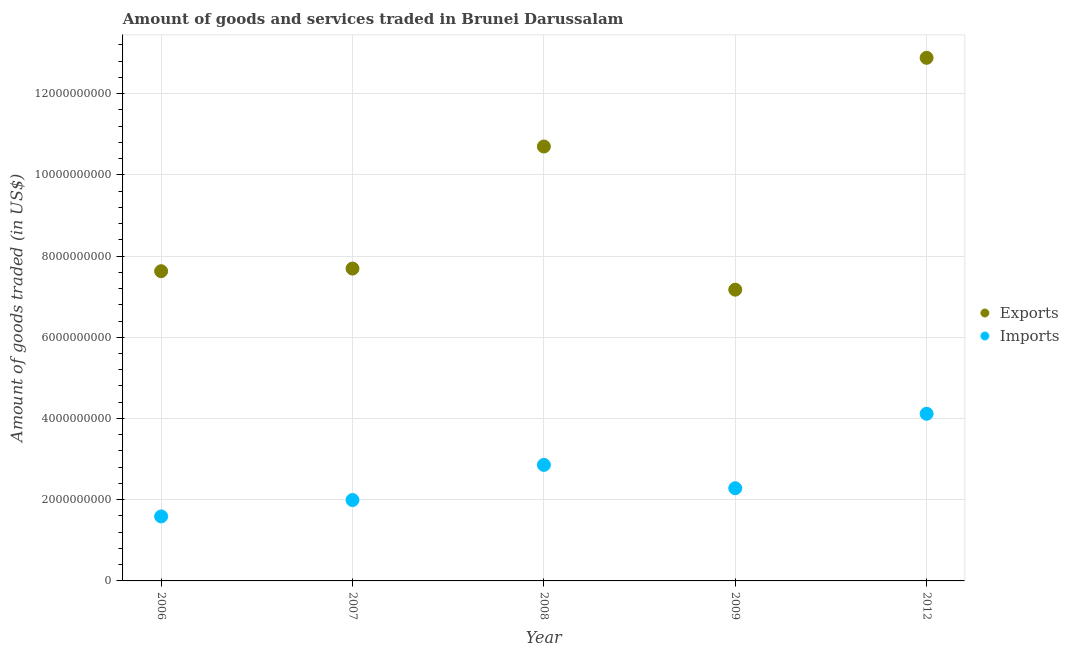What is the amount of goods exported in 2006?
Make the answer very short. 7.63e+09. Across all years, what is the maximum amount of goods imported?
Provide a short and direct response. 4.12e+09. Across all years, what is the minimum amount of goods exported?
Provide a succinct answer. 7.17e+09. In which year was the amount of goods exported maximum?
Provide a short and direct response. 2012. What is the total amount of goods exported in the graph?
Your answer should be very brief. 4.61e+1. What is the difference between the amount of goods imported in 2006 and that in 2012?
Ensure brevity in your answer.  -2.53e+09. What is the difference between the amount of goods exported in 2006 and the amount of goods imported in 2012?
Your answer should be compact. 3.51e+09. What is the average amount of goods exported per year?
Ensure brevity in your answer.  9.21e+09. In the year 2008, what is the difference between the amount of goods exported and amount of goods imported?
Offer a terse response. 7.84e+09. In how many years, is the amount of goods imported greater than 9600000000 US$?
Your answer should be very brief. 0. What is the ratio of the amount of goods exported in 2006 to that in 2007?
Ensure brevity in your answer.  0.99. Is the amount of goods exported in 2007 less than that in 2012?
Your response must be concise. Yes. Is the difference between the amount of goods exported in 2006 and 2012 greater than the difference between the amount of goods imported in 2006 and 2012?
Offer a terse response. No. What is the difference between the highest and the second highest amount of goods exported?
Provide a succinct answer. 2.18e+09. What is the difference between the highest and the lowest amount of goods exported?
Provide a short and direct response. 5.71e+09. In how many years, is the amount of goods imported greater than the average amount of goods imported taken over all years?
Your answer should be compact. 2. Does the amount of goods imported monotonically increase over the years?
Provide a succinct answer. No. Is the amount of goods imported strictly less than the amount of goods exported over the years?
Provide a short and direct response. Yes. How many dotlines are there?
Keep it short and to the point. 2. Are the values on the major ticks of Y-axis written in scientific E-notation?
Give a very brief answer. No. Does the graph contain grids?
Keep it short and to the point. Yes. Where does the legend appear in the graph?
Make the answer very short. Center right. How many legend labels are there?
Ensure brevity in your answer.  2. How are the legend labels stacked?
Provide a succinct answer. Vertical. What is the title of the graph?
Your answer should be compact. Amount of goods and services traded in Brunei Darussalam. What is the label or title of the Y-axis?
Offer a very short reply. Amount of goods traded (in US$). What is the Amount of goods traded (in US$) in Exports in 2006?
Your answer should be compact. 7.63e+09. What is the Amount of goods traded (in US$) of Imports in 2006?
Offer a very short reply. 1.59e+09. What is the Amount of goods traded (in US$) of Exports in 2007?
Give a very brief answer. 7.69e+09. What is the Amount of goods traded (in US$) of Imports in 2007?
Your response must be concise. 1.99e+09. What is the Amount of goods traded (in US$) in Exports in 2008?
Provide a succinct answer. 1.07e+1. What is the Amount of goods traded (in US$) in Imports in 2008?
Keep it short and to the point. 2.86e+09. What is the Amount of goods traded (in US$) of Exports in 2009?
Ensure brevity in your answer.  7.17e+09. What is the Amount of goods traded (in US$) of Imports in 2009?
Your answer should be compact. 2.28e+09. What is the Amount of goods traded (in US$) of Exports in 2012?
Your answer should be compact. 1.29e+1. What is the Amount of goods traded (in US$) in Imports in 2012?
Your response must be concise. 4.12e+09. Across all years, what is the maximum Amount of goods traded (in US$) in Exports?
Make the answer very short. 1.29e+1. Across all years, what is the maximum Amount of goods traded (in US$) of Imports?
Your answer should be compact. 4.12e+09. Across all years, what is the minimum Amount of goods traded (in US$) of Exports?
Make the answer very short. 7.17e+09. Across all years, what is the minimum Amount of goods traded (in US$) of Imports?
Your answer should be compact. 1.59e+09. What is the total Amount of goods traded (in US$) in Exports in the graph?
Your answer should be compact. 4.61e+1. What is the total Amount of goods traded (in US$) in Imports in the graph?
Give a very brief answer. 1.28e+1. What is the difference between the Amount of goods traded (in US$) in Exports in 2006 and that in 2007?
Your answer should be compact. -6.47e+07. What is the difference between the Amount of goods traded (in US$) in Imports in 2006 and that in 2007?
Make the answer very short. -4.03e+08. What is the difference between the Amount of goods traded (in US$) of Exports in 2006 and that in 2008?
Provide a succinct answer. -3.07e+09. What is the difference between the Amount of goods traded (in US$) in Imports in 2006 and that in 2008?
Make the answer very short. -1.27e+09. What is the difference between the Amount of goods traded (in US$) in Exports in 2006 and that in 2009?
Give a very brief answer. 4.55e+08. What is the difference between the Amount of goods traded (in US$) of Imports in 2006 and that in 2009?
Make the answer very short. -6.94e+08. What is the difference between the Amount of goods traded (in US$) of Exports in 2006 and that in 2012?
Make the answer very short. -5.25e+09. What is the difference between the Amount of goods traded (in US$) in Imports in 2006 and that in 2012?
Your answer should be very brief. -2.53e+09. What is the difference between the Amount of goods traded (in US$) in Exports in 2007 and that in 2008?
Your response must be concise. -3.01e+09. What is the difference between the Amount of goods traded (in US$) of Imports in 2007 and that in 2008?
Provide a short and direct response. -8.66e+08. What is the difference between the Amount of goods traded (in US$) in Exports in 2007 and that in 2009?
Give a very brief answer. 5.20e+08. What is the difference between the Amount of goods traded (in US$) in Imports in 2007 and that in 2009?
Give a very brief answer. -2.91e+08. What is the difference between the Amount of goods traded (in US$) of Exports in 2007 and that in 2012?
Your response must be concise. -5.19e+09. What is the difference between the Amount of goods traded (in US$) in Imports in 2007 and that in 2012?
Your answer should be very brief. -2.12e+09. What is the difference between the Amount of goods traded (in US$) in Exports in 2008 and that in 2009?
Offer a very short reply. 3.53e+09. What is the difference between the Amount of goods traded (in US$) of Imports in 2008 and that in 2009?
Offer a very short reply. 5.75e+08. What is the difference between the Amount of goods traded (in US$) of Exports in 2008 and that in 2012?
Offer a very short reply. -2.18e+09. What is the difference between the Amount of goods traded (in US$) of Imports in 2008 and that in 2012?
Make the answer very short. -1.26e+09. What is the difference between the Amount of goods traded (in US$) in Exports in 2009 and that in 2012?
Your answer should be compact. -5.71e+09. What is the difference between the Amount of goods traded (in US$) of Imports in 2009 and that in 2012?
Make the answer very short. -1.83e+09. What is the difference between the Amount of goods traded (in US$) in Exports in 2006 and the Amount of goods traded (in US$) in Imports in 2007?
Your answer should be compact. 5.64e+09. What is the difference between the Amount of goods traded (in US$) in Exports in 2006 and the Amount of goods traded (in US$) in Imports in 2008?
Your answer should be compact. 4.77e+09. What is the difference between the Amount of goods traded (in US$) in Exports in 2006 and the Amount of goods traded (in US$) in Imports in 2009?
Your response must be concise. 5.34e+09. What is the difference between the Amount of goods traded (in US$) in Exports in 2006 and the Amount of goods traded (in US$) in Imports in 2012?
Give a very brief answer. 3.51e+09. What is the difference between the Amount of goods traded (in US$) of Exports in 2007 and the Amount of goods traded (in US$) of Imports in 2008?
Provide a succinct answer. 4.83e+09. What is the difference between the Amount of goods traded (in US$) of Exports in 2007 and the Amount of goods traded (in US$) of Imports in 2009?
Keep it short and to the point. 5.41e+09. What is the difference between the Amount of goods traded (in US$) of Exports in 2007 and the Amount of goods traded (in US$) of Imports in 2012?
Provide a succinct answer. 3.58e+09. What is the difference between the Amount of goods traded (in US$) in Exports in 2008 and the Amount of goods traded (in US$) in Imports in 2009?
Your response must be concise. 8.42e+09. What is the difference between the Amount of goods traded (in US$) in Exports in 2008 and the Amount of goods traded (in US$) in Imports in 2012?
Your response must be concise. 6.58e+09. What is the difference between the Amount of goods traded (in US$) of Exports in 2009 and the Amount of goods traded (in US$) of Imports in 2012?
Offer a very short reply. 3.06e+09. What is the average Amount of goods traded (in US$) of Exports per year?
Provide a succinct answer. 9.21e+09. What is the average Amount of goods traded (in US$) of Imports per year?
Your answer should be compact. 2.57e+09. In the year 2006, what is the difference between the Amount of goods traded (in US$) in Exports and Amount of goods traded (in US$) in Imports?
Provide a succinct answer. 6.04e+09. In the year 2007, what is the difference between the Amount of goods traded (in US$) in Exports and Amount of goods traded (in US$) in Imports?
Make the answer very short. 5.70e+09. In the year 2008, what is the difference between the Amount of goods traded (in US$) of Exports and Amount of goods traded (in US$) of Imports?
Provide a short and direct response. 7.84e+09. In the year 2009, what is the difference between the Amount of goods traded (in US$) in Exports and Amount of goods traded (in US$) in Imports?
Make the answer very short. 4.89e+09. In the year 2012, what is the difference between the Amount of goods traded (in US$) in Exports and Amount of goods traded (in US$) in Imports?
Provide a short and direct response. 8.77e+09. What is the ratio of the Amount of goods traded (in US$) in Imports in 2006 to that in 2007?
Give a very brief answer. 0.8. What is the ratio of the Amount of goods traded (in US$) of Exports in 2006 to that in 2008?
Your response must be concise. 0.71. What is the ratio of the Amount of goods traded (in US$) of Imports in 2006 to that in 2008?
Make the answer very short. 0.56. What is the ratio of the Amount of goods traded (in US$) of Exports in 2006 to that in 2009?
Ensure brevity in your answer.  1.06. What is the ratio of the Amount of goods traded (in US$) of Imports in 2006 to that in 2009?
Give a very brief answer. 0.7. What is the ratio of the Amount of goods traded (in US$) in Exports in 2006 to that in 2012?
Your response must be concise. 0.59. What is the ratio of the Amount of goods traded (in US$) of Imports in 2006 to that in 2012?
Your answer should be very brief. 0.39. What is the ratio of the Amount of goods traded (in US$) of Exports in 2007 to that in 2008?
Provide a succinct answer. 0.72. What is the ratio of the Amount of goods traded (in US$) in Imports in 2007 to that in 2008?
Give a very brief answer. 0.7. What is the ratio of the Amount of goods traded (in US$) in Exports in 2007 to that in 2009?
Offer a very short reply. 1.07. What is the ratio of the Amount of goods traded (in US$) of Imports in 2007 to that in 2009?
Keep it short and to the point. 0.87. What is the ratio of the Amount of goods traded (in US$) in Exports in 2007 to that in 2012?
Your response must be concise. 0.6. What is the ratio of the Amount of goods traded (in US$) in Imports in 2007 to that in 2012?
Your answer should be compact. 0.48. What is the ratio of the Amount of goods traded (in US$) of Exports in 2008 to that in 2009?
Your answer should be very brief. 1.49. What is the ratio of the Amount of goods traded (in US$) of Imports in 2008 to that in 2009?
Your answer should be compact. 1.25. What is the ratio of the Amount of goods traded (in US$) of Exports in 2008 to that in 2012?
Offer a terse response. 0.83. What is the ratio of the Amount of goods traded (in US$) in Imports in 2008 to that in 2012?
Give a very brief answer. 0.69. What is the ratio of the Amount of goods traded (in US$) in Exports in 2009 to that in 2012?
Provide a succinct answer. 0.56. What is the ratio of the Amount of goods traded (in US$) of Imports in 2009 to that in 2012?
Give a very brief answer. 0.55. What is the difference between the highest and the second highest Amount of goods traded (in US$) of Exports?
Provide a short and direct response. 2.18e+09. What is the difference between the highest and the second highest Amount of goods traded (in US$) of Imports?
Offer a terse response. 1.26e+09. What is the difference between the highest and the lowest Amount of goods traded (in US$) of Exports?
Give a very brief answer. 5.71e+09. What is the difference between the highest and the lowest Amount of goods traded (in US$) of Imports?
Offer a very short reply. 2.53e+09. 